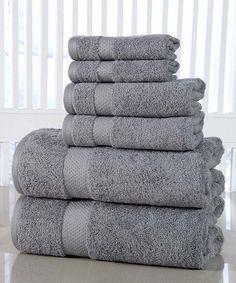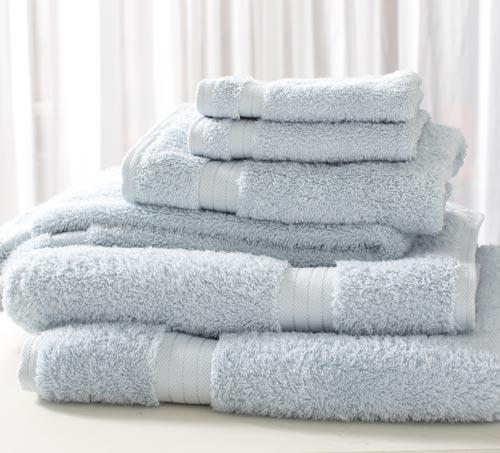The first image is the image on the left, the second image is the image on the right. Assess this claim about the two images: "The leftmost images feature a stack of grey towels.". Correct or not? Answer yes or no. Yes. The first image is the image on the left, the second image is the image on the right. Given the left and right images, does the statement "The towels in the image on the left are gray." hold true? Answer yes or no. Yes. 